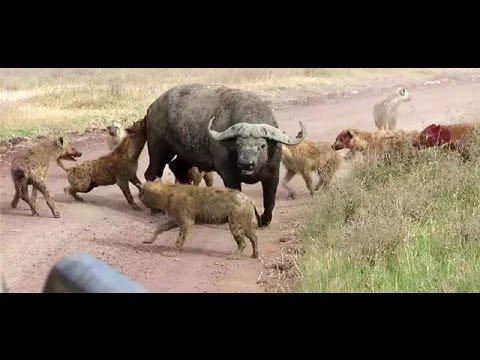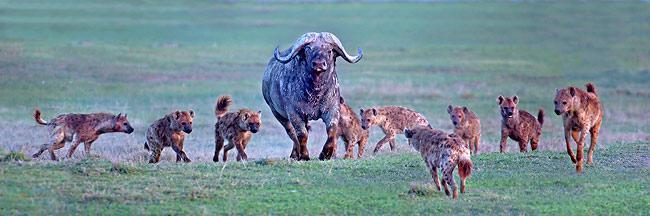The first image is the image on the left, the second image is the image on the right. Evaluate the accuracy of this statement regarding the images: "an animal is being eaten on the left pic". Is it true? Answer yes or no. No. The first image is the image on the left, the second image is the image on the right. Examine the images to the left and right. Is the description "Hyenas are circling their prey, which is still up on all 4 legs in both images." accurate? Answer yes or no. Yes. 